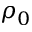Convert formula to latex. <formula><loc_0><loc_0><loc_500><loc_500>\rho _ { 0 }</formula> 